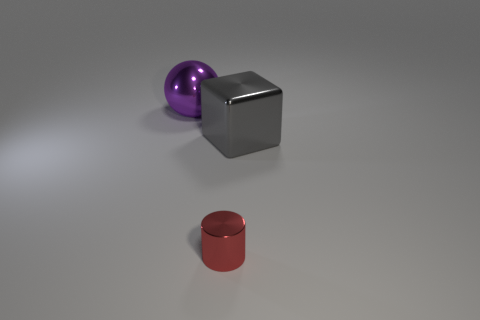Does the large metal cube have the same color as the tiny cylinder?
Provide a short and direct response. No. How many purple objects are either tiny objects or balls?
Make the answer very short. 1. Are there any big balls in front of the small red cylinder?
Give a very brief answer. No. How big is the cylinder?
Make the answer very short. Small. How many large spheres are on the left side of the thing left of the tiny metal thing?
Ensure brevity in your answer.  0. Are the big object that is left of the tiny metallic cylinder and the thing in front of the gray cube made of the same material?
Provide a short and direct response. Yes. What number of other purple metallic things are the same shape as the purple object?
Make the answer very short. 0. There is a metal thing in front of the gray metal cube; is its shape the same as the metal thing left of the small cylinder?
Your response must be concise. No. There is a big object on the right side of the big object to the left of the tiny red metallic cylinder; what number of purple shiny things are to the left of it?
Make the answer very short. 1. There is a large thing behind the large thing that is in front of the ball that is behind the gray thing; what is it made of?
Keep it short and to the point. Metal. 